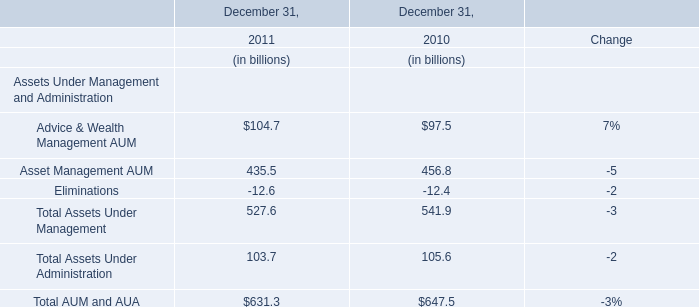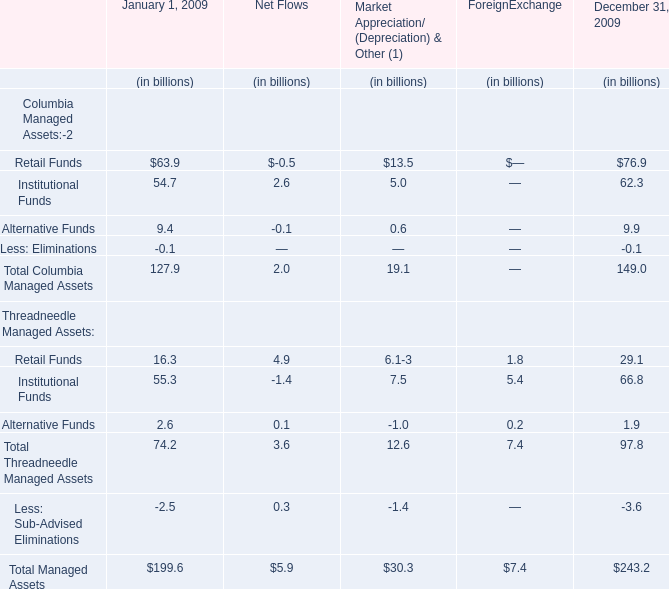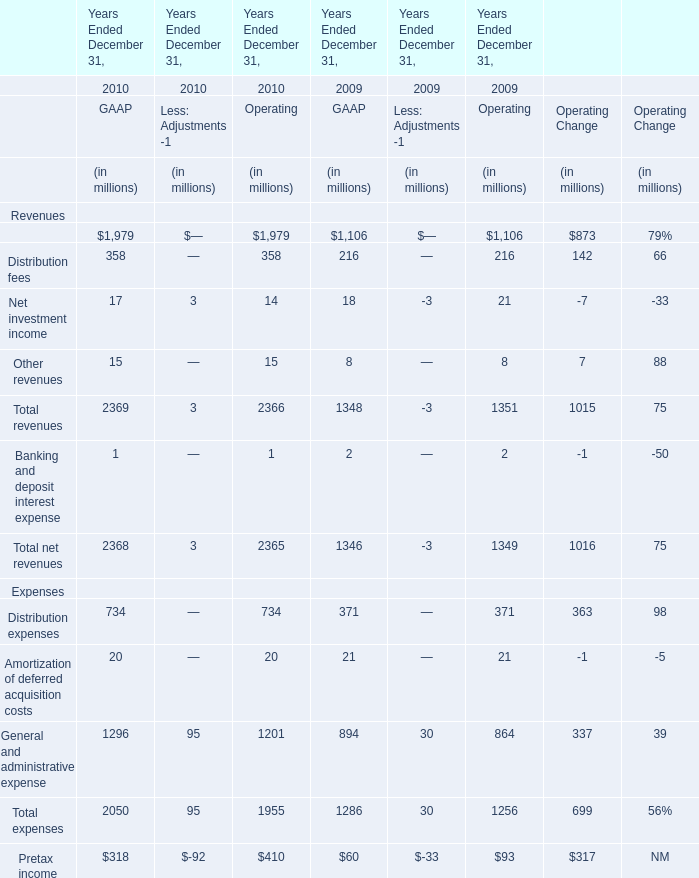In what year is distribution expenses greater than 700? 
Answer: 734. 